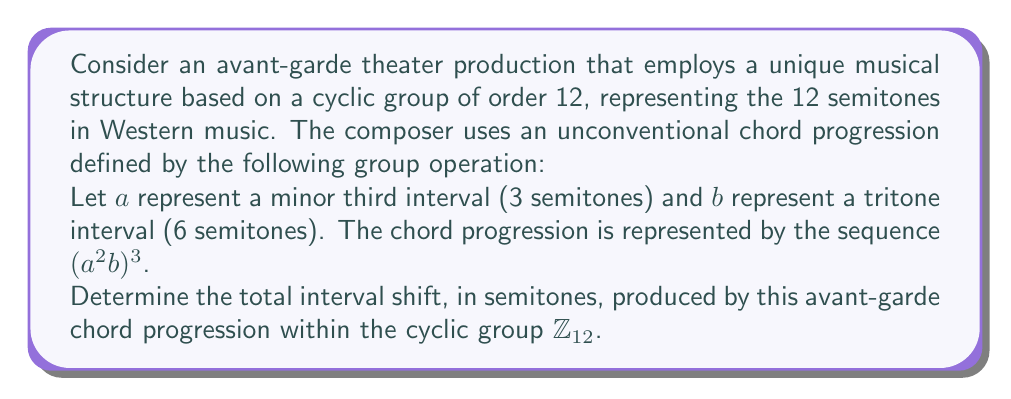What is the answer to this math problem? To solve this problem, we need to analyze the group operation within $\mathbb{Z}_{12}$:

1) First, let's define our elements:
   $a = 3$ (minor third, 3 semitones)
   $b = 6$ (tritone, 6 semitones)

2) The sequence is $(a^2b)^3$, so we need to calculate $a^2b$ first, then apply it three times:

   $a^2 = 3 + 3 = 6$ (mod 12)
   $a^2b = 6 + 6 = 0$ (mod 12)

3) Now, we need to apply $(a^2b)^3$:

   $(a^2b)^3 = (0) + (0) + (0) = 0$ (mod 12)

4) The result is 0, which means that after applying this chord progression, we end up at the same note we started with in the 12-tone system.

This result showcases a mathematically intriguing property of this avant-garde composition: despite its complex appearance, the chord progression creates a complete cycle, returning to its starting point. This could be interpreted as a musical representation of the cyclic nature of the group $\mathbb{Z}_{12}$.
Answer: The total interval shift produced by the chord progression $(a^2b)^3$ is 0 semitones in $\mathbb{Z}_{12}$. 